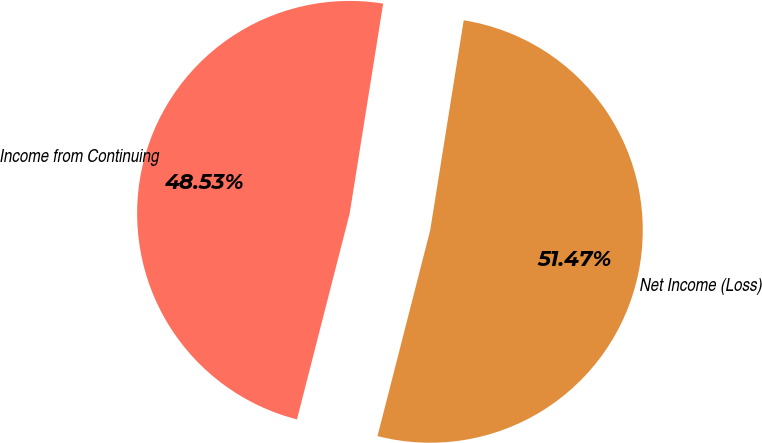<chart> <loc_0><loc_0><loc_500><loc_500><pie_chart><fcel>Income from Continuing<fcel>Net Income (Loss)<nl><fcel>48.53%<fcel>51.47%<nl></chart> 